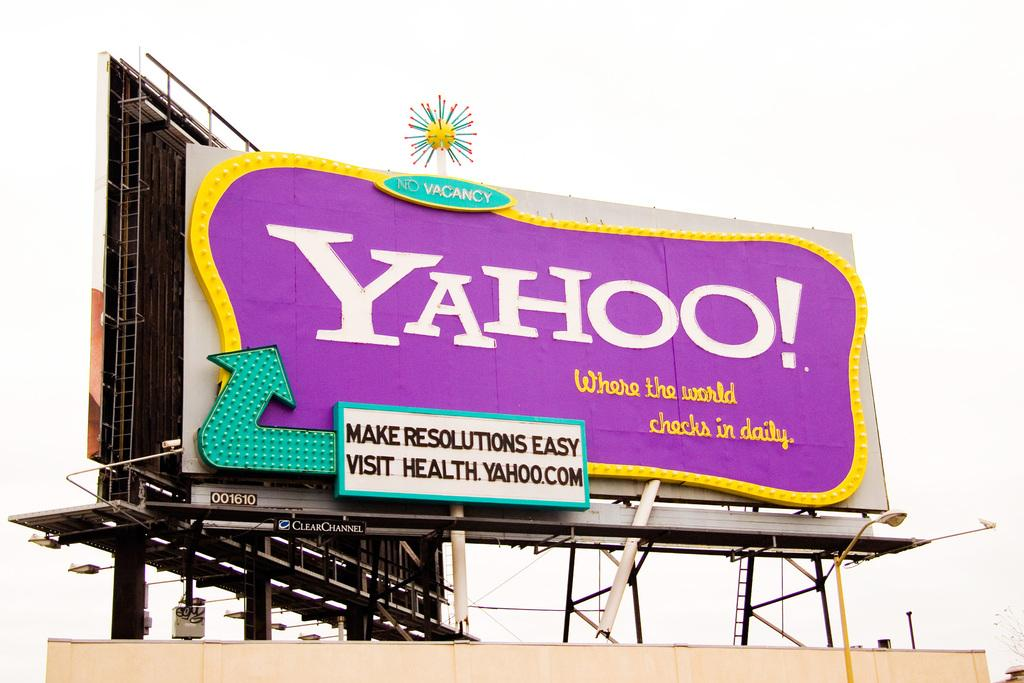Provide a one-sentence caption for the provided image. You could visit health.yahoo.com to make resolutions easy, according to this billboard. 